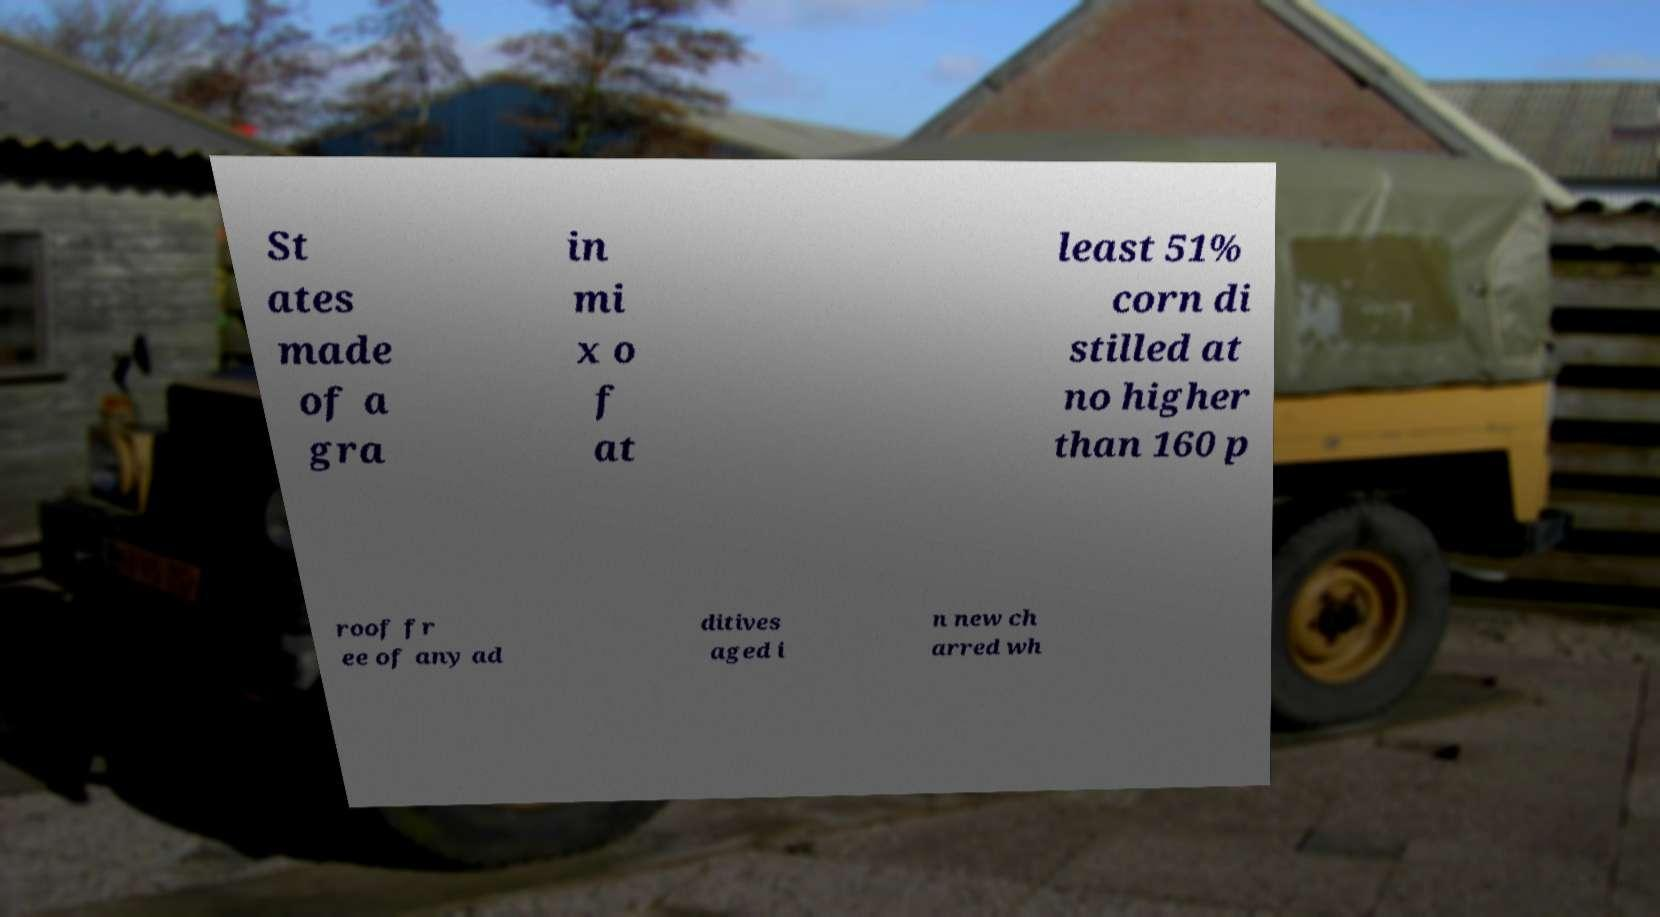There's text embedded in this image that I need extracted. Can you transcribe it verbatim? St ates made of a gra in mi x o f at least 51% corn di stilled at no higher than 160 p roof fr ee of any ad ditives aged i n new ch arred wh 